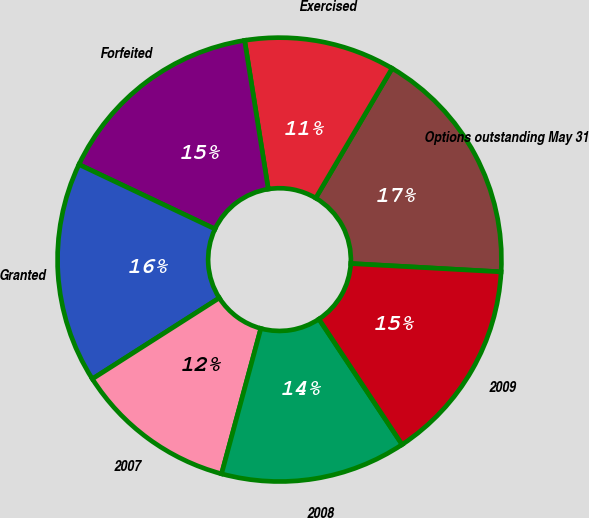Convert chart to OTSL. <chart><loc_0><loc_0><loc_500><loc_500><pie_chart><fcel>Options outstanding May 31<fcel>Exercised<fcel>Forfeited<fcel>Granted<fcel>2007<fcel>2008<fcel>2009<nl><fcel>17.41%<fcel>10.98%<fcel>15.44%<fcel>16.08%<fcel>11.76%<fcel>13.52%<fcel>14.8%<nl></chart> 